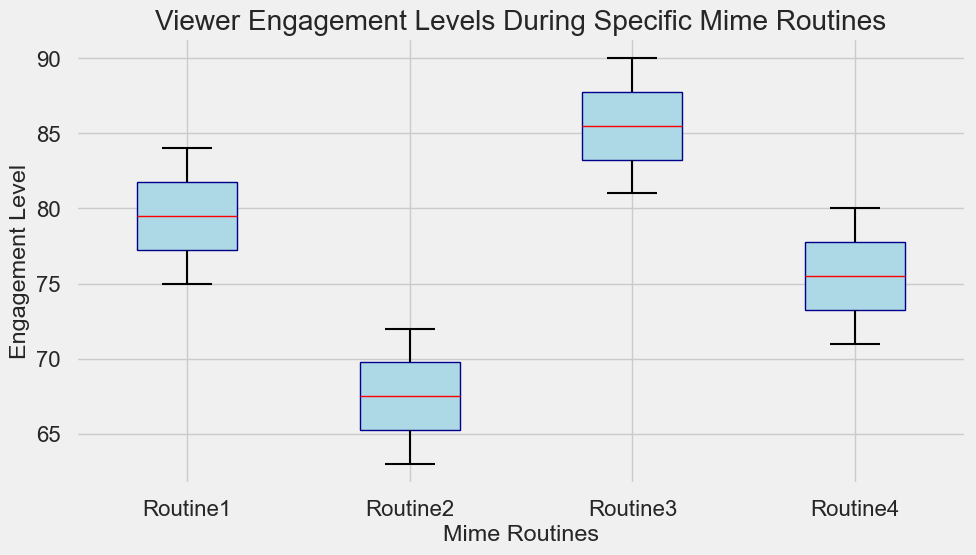Which routine has the highest median engagement level? To identify the highest median engagement level, look for the red median line in each box. Routine 3 has the highest median line.
Answer: Routine 3 Which routine has the lowest range of engagement levels? The range of engagement levels is depicted by the length from the bottom whisker to the top whisker. Routine 4 has the shortest distance between these points.
Answer: Routine 4 Compare the median engagement levels of Routine 1 and Routine 2. Which one is higher? To compare the medians, check the red lines; Routine 1's median is higher than Routine 2's.
Answer: Routine 1 What can you infer about the variability of engagement levels in Routine 3 compared to Routine 2? The box (interquartile range) and the whiskers (total range) for Routine 3 are both larger compared to Routine 2, indicating more variability.
Answer: Higher variability Is there any routine with an outlier and which one? Outliers are indicated by dots outside the whiskers. None of the routines have dots outside the whiskers in this plot.
Answer: No outliers Which routine has the greatest upper quartile engagement level? The upper quartile is the top of the box. Routine 3 has the highest top edge of the box.
Answer: Routine 3 By roughly how much does the median engagement level of Routine 1 exceed Routine 4? Routine 1's median engagement level is around 80, while Routine 4's is approximately 74. So, 80 - 74 = 6.
Answer: 6 Which routine shows the closest first and third quartile range (i.e., smallest interquartile range)? The interquartile range is the box length. Routine 4 has the smallest box, indicating the closest first and third quartile range.
Answer: Routine 4 What is the interquartile range for Routine 2? The interquartile range is the difference between the third and first quartile. For Routine 2, it's approximately 70 - 65 = 5.
Answer: 5 